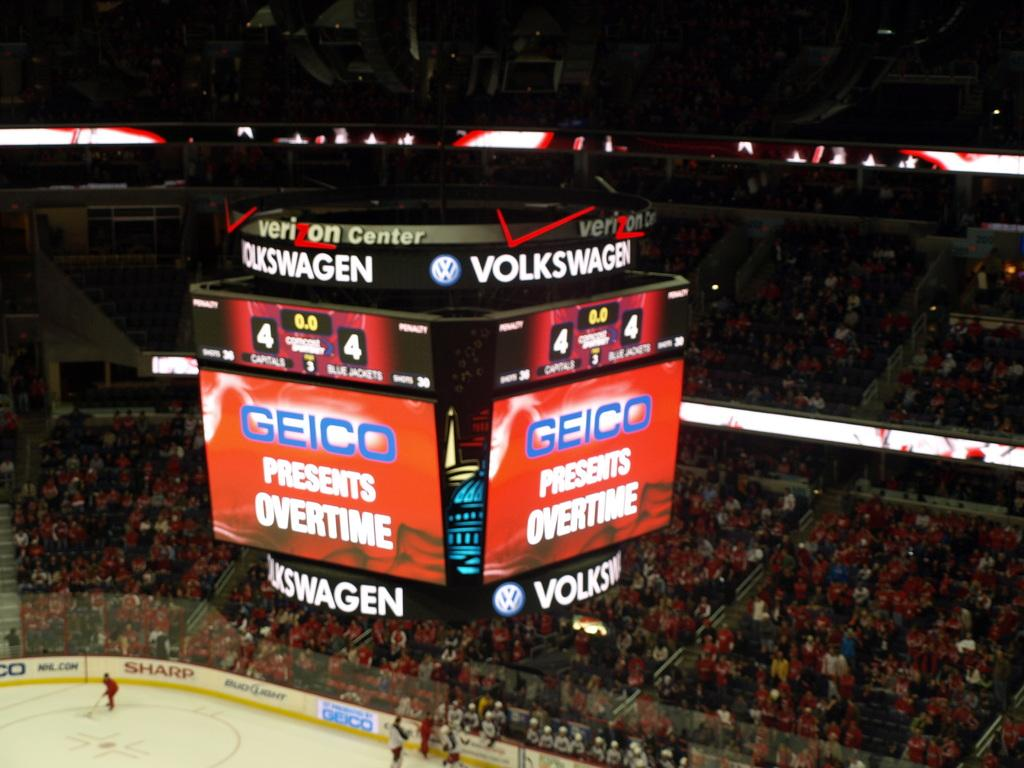What is the main feature of the image? There is a scoreboard in the image. Where are the people located in the image? There are people in the stands and on the ground playing a game. What might the people in the stands be doing? The people in the stands might be watching the game being played on the ground. What type of recess is shown in the image? There is no recess present in the image; it features a scoreboard, people in the stands, and people playing a game on the ground. Can you provide an example of a similar game being played in another location? The image only shows the game being played in the specific location depicted, so it is not possible to provide an example of a similar game being played in another location. 